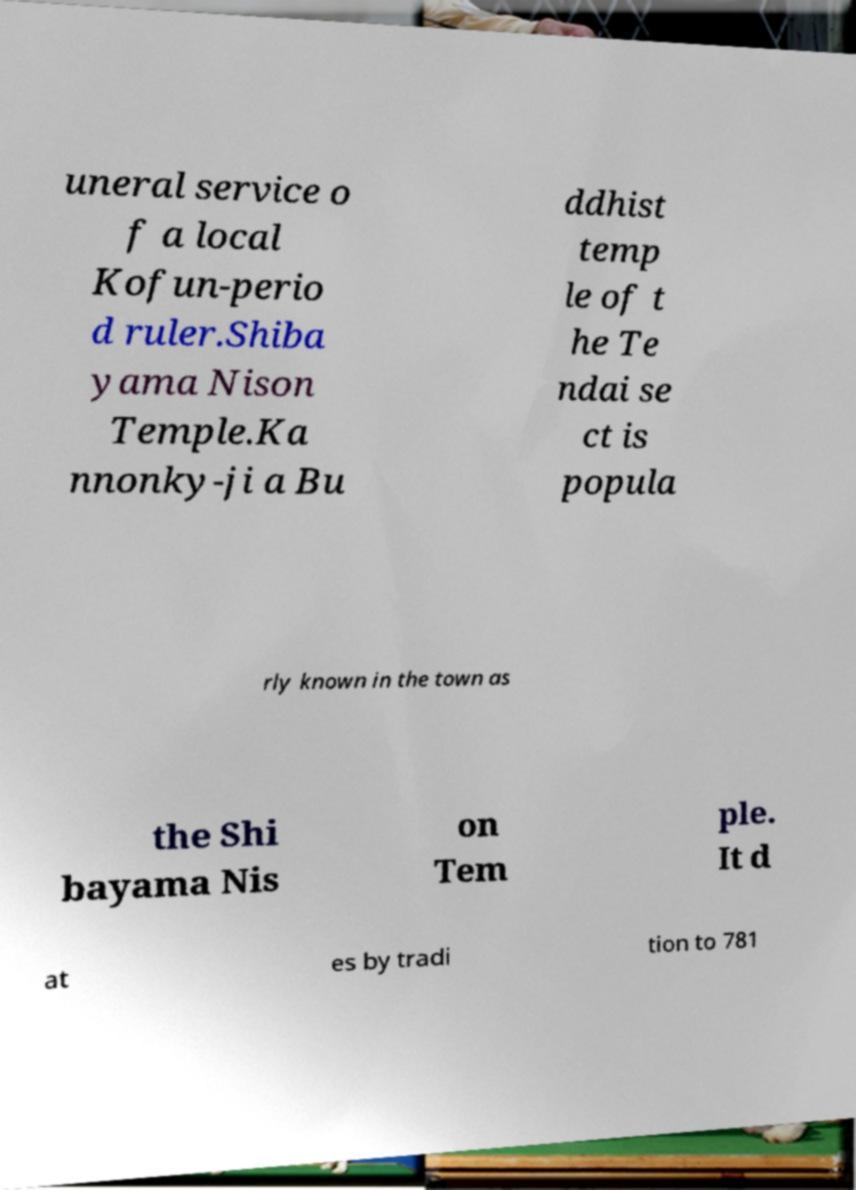Could you extract and type out the text from this image? uneral service o f a local Kofun-perio d ruler.Shiba yama Nison Temple.Ka nnonky-ji a Bu ddhist temp le of t he Te ndai se ct is popula rly known in the town as the Shi bayama Nis on Tem ple. It d at es by tradi tion to 781 